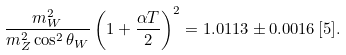<formula> <loc_0><loc_0><loc_500><loc_500>\frac { m _ { W } ^ { 2 } } { m _ { Z } ^ { 2 } \cos ^ { 2 } { \theta _ { W } } } \left ( 1 + \frac { \alpha T } { 2 } \right ) ^ { 2 } = 1 . 0 1 1 3 \pm 0 . 0 0 1 6 \, [ 5 ] .</formula> 